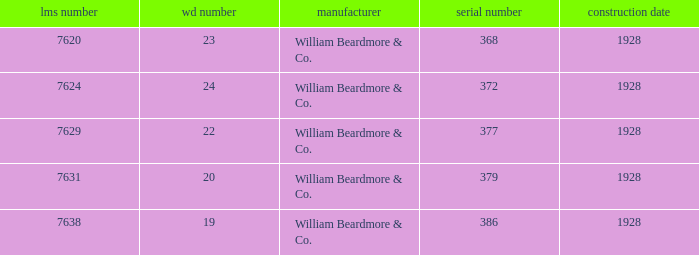Name the total number of serial number for 24 wd no 1.0. 